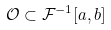Convert formula to latex. <formula><loc_0><loc_0><loc_500><loc_500>\mathcal { O } \subset \mathcal { F } ^ { - 1 } [ a , b ]</formula> 